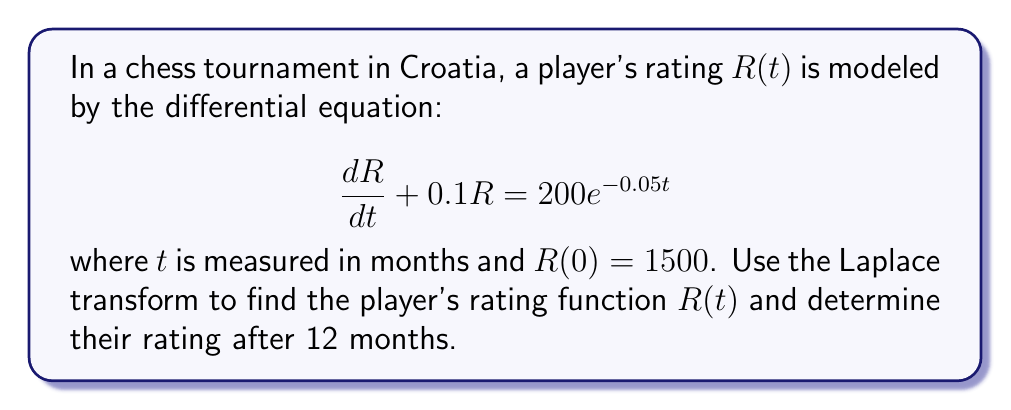Help me with this question. Let's solve this problem step by step using the Laplace transform:

1) Take the Laplace transform of both sides of the differential equation:

   $\mathcal{L}\{\frac{dR}{dt} + 0.1R\} = \mathcal{L}\{200e^{-0.05t}\}$

2) Using Laplace transform properties:

   $s\mathcal{L}\{R\} - R(0) + 0.1\mathcal{L}\{R\} = \frac{200}{s+0.05}$

3) Let $\mathcal{L}\{R\} = X(s)$. Substitute $R(0) = 1500$:

   $sX(s) - 1500 + 0.1X(s) = \frac{200}{s+0.05}$

4) Solve for $X(s)$:

   $(s+0.1)X(s) = 1500 + \frac{200}{s+0.05}$

   $X(s) = \frac{1500}{s+0.1} + \frac{200}{(s+0.1)(s+0.05)}$

5) Perform partial fraction decomposition:

   $X(s) = \frac{1500}{s+0.1} + \frac{4000}{s+0.1} - \frac{4000}{s+0.05}$

   $X(s) = \frac{5500}{s+0.1} - \frac{4000}{s+0.05}$

6) Take the inverse Laplace transform:

   $R(t) = 5500e^{-0.1t} - 4000e^{-0.05t}$

7) To find the rating after 12 months, substitute $t=12$:

   $R(12) = 5500e^{-0.1(12)} - 4000e^{-0.05(12)}$
          $= 5500e^{-1.2} - 4000e^{-0.6}$
          $\approx 1656.85$
Answer: The player's rating function is $R(t) = 5500e^{-0.1t} - 4000e^{-0.05t}$, and their rating after 12 months is approximately 1657 (rounded to the nearest integer). 